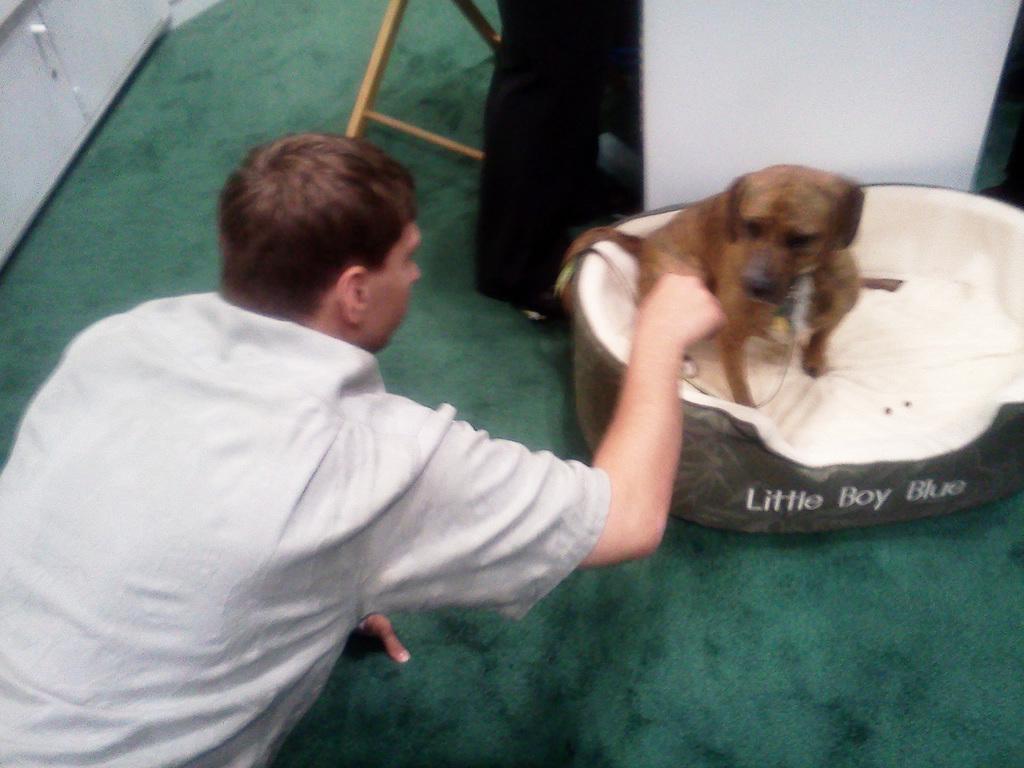Please provide a concise description of this image. This picture shows a man is playing with a dog, and the dog is in the tub. In the background we can see cupboards. 